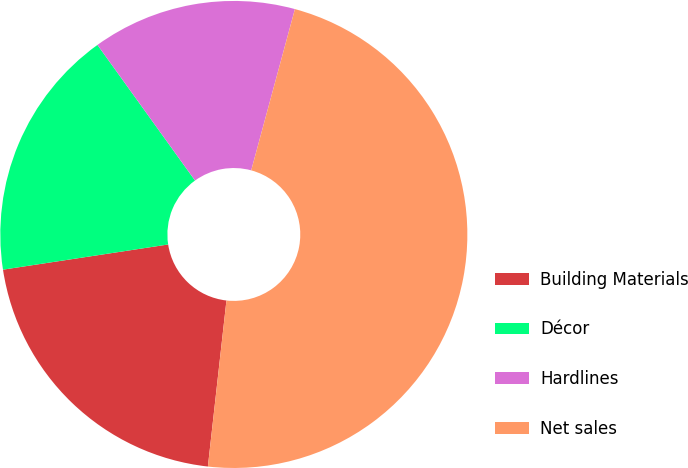Convert chart to OTSL. <chart><loc_0><loc_0><loc_500><loc_500><pie_chart><fcel>Building Materials<fcel>Décor<fcel>Hardlines<fcel>Net sales<nl><fcel>20.82%<fcel>17.48%<fcel>14.14%<fcel>47.56%<nl></chart> 